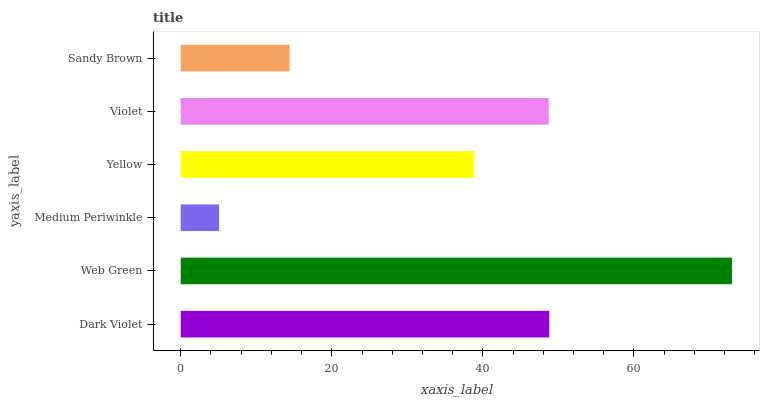Is Medium Periwinkle the minimum?
Answer yes or no. Yes. Is Web Green the maximum?
Answer yes or no. Yes. Is Web Green the minimum?
Answer yes or no. No. Is Medium Periwinkle the maximum?
Answer yes or no. No. Is Web Green greater than Medium Periwinkle?
Answer yes or no. Yes. Is Medium Periwinkle less than Web Green?
Answer yes or no. Yes. Is Medium Periwinkle greater than Web Green?
Answer yes or no. No. Is Web Green less than Medium Periwinkle?
Answer yes or no. No. Is Violet the high median?
Answer yes or no. Yes. Is Yellow the low median?
Answer yes or no. Yes. Is Web Green the high median?
Answer yes or no. No. Is Medium Periwinkle the low median?
Answer yes or no. No. 